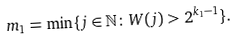<formula> <loc_0><loc_0><loc_500><loc_500>m _ { 1 } = \min \{ j \in \mathbb { N } \colon W ( j ) > 2 ^ { k _ { 1 } - 1 } \} .</formula> 